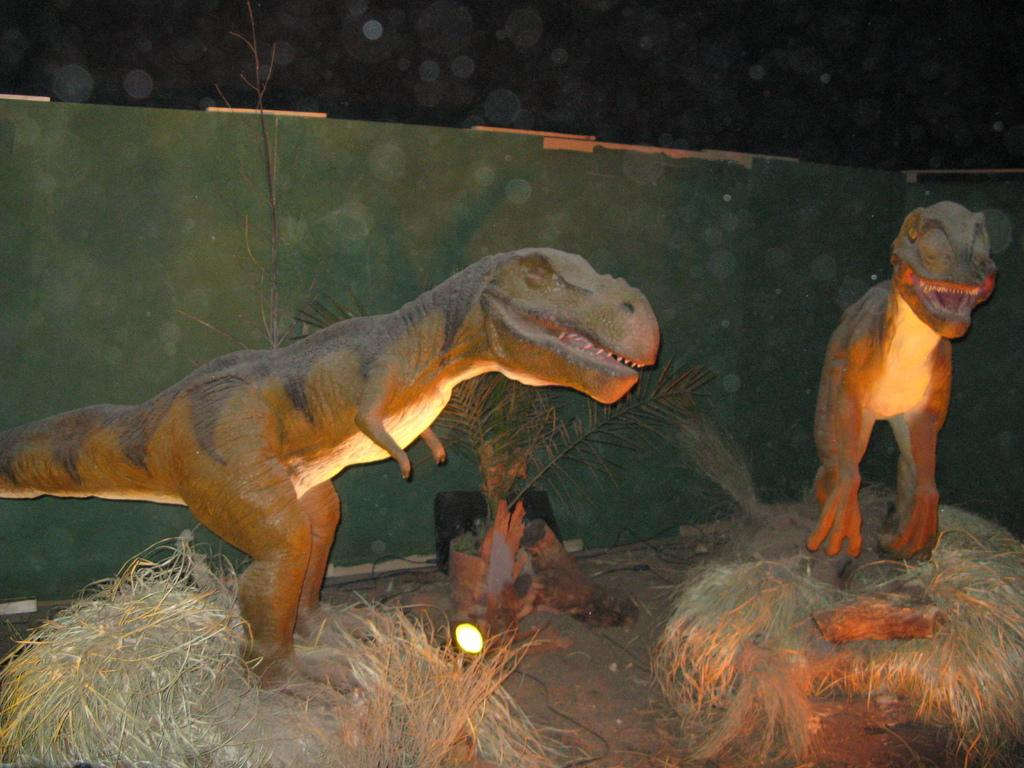What type of figures can be seen in the image? There are statues of dinosaurs in the image. What is the condition of the vegetation in the image? There is dry grass visible in the image. What can be seen on the path in the image? There is a light and a plant on the path in the image. What type of dinner is being served by the grandmother in the image? There is no dinner or grandmother present in the image; it features statues of dinosaurs, dry grass, a light, and a plant on the path. 